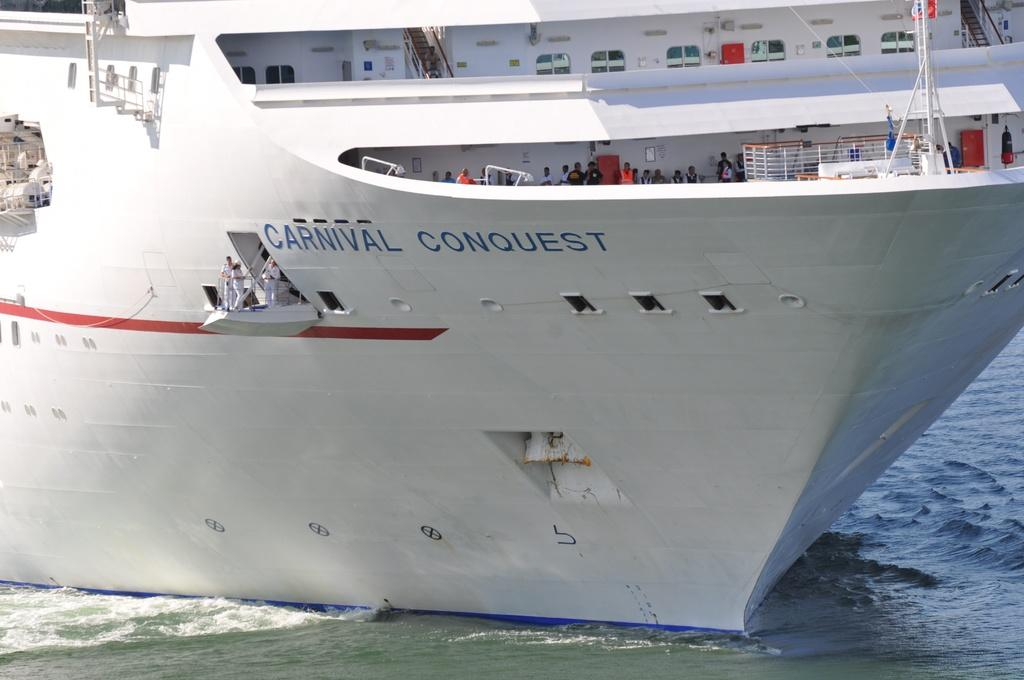What is the main subject of the image? The main subject of the image is a ship above the water. Are there any people on the ship? Yes, there are people in the ship. What feature can be seen on the ship? The ship has windows. What type of cord is being used to control the ship's movements in the image? There is no cord visible in the image, and the ship's movements are not mentioned in the facts provided. 